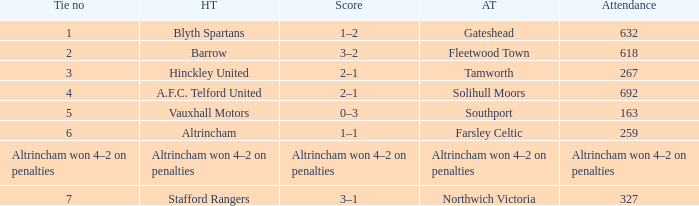Which home team had the away team Southport? Vauxhall Motors. Parse the table in full. {'header': ['Tie no', 'HT', 'Score', 'AT', 'Attendance'], 'rows': [['1', 'Blyth Spartans', '1–2', 'Gateshead', '632'], ['2', 'Barrow', '3–2', 'Fleetwood Town', '618'], ['3', 'Hinckley United', '2–1', 'Tamworth', '267'], ['4', 'A.F.C. Telford United', '2–1', 'Solihull Moors', '692'], ['5', 'Vauxhall Motors', '0–3', 'Southport', '163'], ['6', 'Altrincham', '1–1', 'Farsley Celtic', '259'], ['Altrincham won 4–2 on penalties', 'Altrincham won 4–2 on penalties', 'Altrincham won 4–2 on penalties', 'Altrincham won 4–2 on penalties', 'Altrincham won 4–2 on penalties'], ['7', 'Stafford Rangers', '3–1', 'Northwich Victoria', '327']]} 